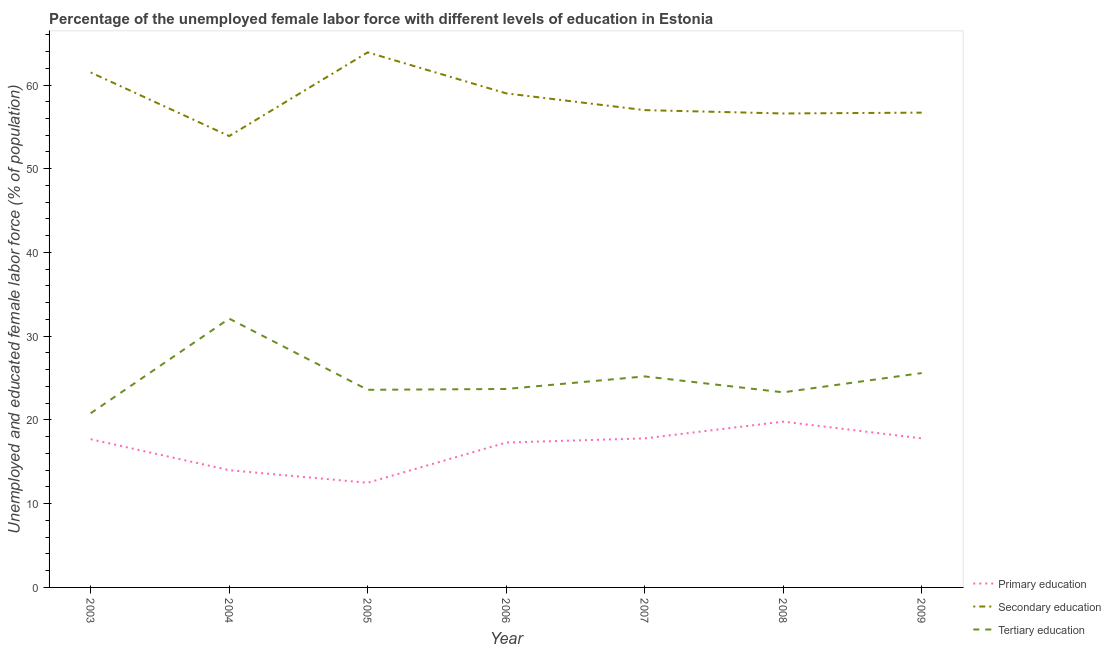Does the line corresponding to percentage of female labor force who received tertiary education intersect with the line corresponding to percentage of female labor force who received secondary education?
Ensure brevity in your answer.  No. Is the number of lines equal to the number of legend labels?
Make the answer very short. Yes. What is the percentage of female labor force who received secondary education in 2003?
Keep it short and to the point. 61.5. Across all years, what is the maximum percentage of female labor force who received primary education?
Keep it short and to the point. 19.8. Across all years, what is the minimum percentage of female labor force who received tertiary education?
Give a very brief answer. 20.8. What is the total percentage of female labor force who received secondary education in the graph?
Keep it short and to the point. 408.6. What is the difference between the percentage of female labor force who received primary education in 2003 and that in 2004?
Your response must be concise. 3.7. What is the difference between the percentage of female labor force who received primary education in 2008 and the percentage of female labor force who received secondary education in 2004?
Offer a very short reply. -34.1. What is the average percentage of female labor force who received secondary education per year?
Your answer should be very brief. 58.37. In the year 2006, what is the difference between the percentage of female labor force who received secondary education and percentage of female labor force who received primary education?
Keep it short and to the point. 41.7. In how many years, is the percentage of female labor force who received primary education greater than 54 %?
Your answer should be compact. 0. What is the ratio of the percentage of female labor force who received primary education in 2005 to that in 2007?
Make the answer very short. 0.7. Is the percentage of female labor force who received secondary education in 2005 less than that in 2006?
Provide a succinct answer. No. Is the difference between the percentage of female labor force who received tertiary education in 2003 and 2007 greater than the difference between the percentage of female labor force who received secondary education in 2003 and 2007?
Make the answer very short. No. What is the difference between the highest and the second highest percentage of female labor force who received primary education?
Provide a succinct answer. 2. What is the difference between the highest and the lowest percentage of female labor force who received tertiary education?
Offer a terse response. 11.3. Does the percentage of female labor force who received tertiary education monotonically increase over the years?
Provide a succinct answer. No. Is the percentage of female labor force who received primary education strictly greater than the percentage of female labor force who received tertiary education over the years?
Keep it short and to the point. No. Does the graph contain any zero values?
Offer a very short reply. No. Does the graph contain grids?
Make the answer very short. No. Where does the legend appear in the graph?
Provide a short and direct response. Bottom right. How many legend labels are there?
Your response must be concise. 3. How are the legend labels stacked?
Offer a terse response. Vertical. What is the title of the graph?
Your answer should be very brief. Percentage of the unemployed female labor force with different levels of education in Estonia. Does "Industry" appear as one of the legend labels in the graph?
Offer a very short reply. No. What is the label or title of the X-axis?
Make the answer very short. Year. What is the label or title of the Y-axis?
Keep it short and to the point. Unemployed and educated female labor force (% of population). What is the Unemployed and educated female labor force (% of population) in Primary education in 2003?
Make the answer very short. 17.7. What is the Unemployed and educated female labor force (% of population) of Secondary education in 2003?
Keep it short and to the point. 61.5. What is the Unemployed and educated female labor force (% of population) in Tertiary education in 2003?
Provide a succinct answer. 20.8. What is the Unemployed and educated female labor force (% of population) of Secondary education in 2004?
Your response must be concise. 53.9. What is the Unemployed and educated female labor force (% of population) in Tertiary education in 2004?
Your answer should be very brief. 32.1. What is the Unemployed and educated female labor force (% of population) of Secondary education in 2005?
Offer a very short reply. 63.9. What is the Unemployed and educated female labor force (% of population) of Tertiary education in 2005?
Your answer should be compact. 23.6. What is the Unemployed and educated female labor force (% of population) in Primary education in 2006?
Give a very brief answer. 17.3. What is the Unemployed and educated female labor force (% of population) of Tertiary education in 2006?
Provide a succinct answer. 23.7. What is the Unemployed and educated female labor force (% of population) in Primary education in 2007?
Your answer should be very brief. 17.8. What is the Unemployed and educated female labor force (% of population) in Tertiary education in 2007?
Your answer should be very brief. 25.2. What is the Unemployed and educated female labor force (% of population) of Primary education in 2008?
Your answer should be very brief. 19.8. What is the Unemployed and educated female labor force (% of population) of Secondary education in 2008?
Ensure brevity in your answer.  56.6. What is the Unemployed and educated female labor force (% of population) of Tertiary education in 2008?
Offer a very short reply. 23.3. What is the Unemployed and educated female labor force (% of population) of Primary education in 2009?
Offer a terse response. 17.8. What is the Unemployed and educated female labor force (% of population) of Secondary education in 2009?
Your answer should be very brief. 56.7. What is the Unemployed and educated female labor force (% of population) of Tertiary education in 2009?
Give a very brief answer. 25.6. Across all years, what is the maximum Unemployed and educated female labor force (% of population) of Primary education?
Your answer should be very brief. 19.8. Across all years, what is the maximum Unemployed and educated female labor force (% of population) of Secondary education?
Offer a very short reply. 63.9. Across all years, what is the maximum Unemployed and educated female labor force (% of population) of Tertiary education?
Offer a very short reply. 32.1. Across all years, what is the minimum Unemployed and educated female labor force (% of population) of Secondary education?
Give a very brief answer. 53.9. Across all years, what is the minimum Unemployed and educated female labor force (% of population) of Tertiary education?
Your response must be concise. 20.8. What is the total Unemployed and educated female labor force (% of population) in Primary education in the graph?
Provide a succinct answer. 116.9. What is the total Unemployed and educated female labor force (% of population) of Secondary education in the graph?
Offer a very short reply. 408.6. What is the total Unemployed and educated female labor force (% of population) of Tertiary education in the graph?
Offer a terse response. 174.3. What is the difference between the Unemployed and educated female labor force (% of population) of Primary education in 2003 and that in 2004?
Provide a succinct answer. 3.7. What is the difference between the Unemployed and educated female labor force (% of population) of Tertiary education in 2003 and that in 2004?
Provide a short and direct response. -11.3. What is the difference between the Unemployed and educated female labor force (% of population) of Secondary education in 2003 and that in 2005?
Your response must be concise. -2.4. What is the difference between the Unemployed and educated female labor force (% of population) of Tertiary education in 2003 and that in 2006?
Your answer should be very brief. -2.9. What is the difference between the Unemployed and educated female labor force (% of population) in Primary education in 2003 and that in 2007?
Give a very brief answer. -0.1. What is the difference between the Unemployed and educated female labor force (% of population) in Secondary education in 2003 and that in 2008?
Make the answer very short. 4.9. What is the difference between the Unemployed and educated female labor force (% of population) of Tertiary education in 2003 and that in 2008?
Offer a very short reply. -2.5. What is the difference between the Unemployed and educated female labor force (% of population) in Tertiary education in 2003 and that in 2009?
Keep it short and to the point. -4.8. What is the difference between the Unemployed and educated female labor force (% of population) of Primary education in 2004 and that in 2005?
Give a very brief answer. 1.5. What is the difference between the Unemployed and educated female labor force (% of population) in Tertiary education in 2004 and that in 2005?
Give a very brief answer. 8.5. What is the difference between the Unemployed and educated female labor force (% of population) of Secondary education in 2004 and that in 2006?
Keep it short and to the point. -5.1. What is the difference between the Unemployed and educated female labor force (% of population) of Secondary education in 2004 and that in 2007?
Offer a terse response. -3.1. What is the difference between the Unemployed and educated female labor force (% of population) of Tertiary education in 2004 and that in 2007?
Offer a terse response. 6.9. What is the difference between the Unemployed and educated female labor force (% of population) of Tertiary education in 2004 and that in 2008?
Offer a terse response. 8.8. What is the difference between the Unemployed and educated female labor force (% of population) in Primary education in 2004 and that in 2009?
Your answer should be very brief. -3.8. What is the difference between the Unemployed and educated female labor force (% of population) in Tertiary education in 2005 and that in 2006?
Keep it short and to the point. -0.1. What is the difference between the Unemployed and educated female labor force (% of population) of Secondary education in 2005 and that in 2007?
Keep it short and to the point. 6.9. What is the difference between the Unemployed and educated female labor force (% of population) in Tertiary education in 2005 and that in 2007?
Make the answer very short. -1.6. What is the difference between the Unemployed and educated female labor force (% of population) of Primary education in 2005 and that in 2008?
Make the answer very short. -7.3. What is the difference between the Unemployed and educated female labor force (% of population) of Secondary education in 2005 and that in 2008?
Make the answer very short. 7.3. What is the difference between the Unemployed and educated female labor force (% of population) in Tertiary education in 2005 and that in 2008?
Offer a very short reply. 0.3. What is the difference between the Unemployed and educated female labor force (% of population) in Primary education in 2005 and that in 2009?
Provide a succinct answer. -5.3. What is the difference between the Unemployed and educated female labor force (% of population) in Primary education in 2006 and that in 2007?
Ensure brevity in your answer.  -0.5. What is the difference between the Unemployed and educated female labor force (% of population) in Secondary education in 2006 and that in 2007?
Give a very brief answer. 2. What is the difference between the Unemployed and educated female labor force (% of population) of Tertiary education in 2006 and that in 2007?
Keep it short and to the point. -1.5. What is the difference between the Unemployed and educated female labor force (% of population) of Primary education in 2006 and that in 2008?
Your response must be concise. -2.5. What is the difference between the Unemployed and educated female labor force (% of population) of Secondary education in 2006 and that in 2009?
Offer a terse response. 2.3. What is the difference between the Unemployed and educated female labor force (% of population) of Tertiary education in 2006 and that in 2009?
Your answer should be very brief. -1.9. What is the difference between the Unemployed and educated female labor force (% of population) in Primary education in 2007 and that in 2008?
Offer a very short reply. -2. What is the difference between the Unemployed and educated female labor force (% of population) in Secondary education in 2007 and that in 2008?
Ensure brevity in your answer.  0.4. What is the difference between the Unemployed and educated female labor force (% of population) of Tertiary education in 2007 and that in 2008?
Make the answer very short. 1.9. What is the difference between the Unemployed and educated female labor force (% of population) of Primary education in 2008 and that in 2009?
Offer a terse response. 2. What is the difference between the Unemployed and educated female labor force (% of population) of Tertiary education in 2008 and that in 2009?
Offer a very short reply. -2.3. What is the difference between the Unemployed and educated female labor force (% of population) of Primary education in 2003 and the Unemployed and educated female labor force (% of population) of Secondary education in 2004?
Your response must be concise. -36.2. What is the difference between the Unemployed and educated female labor force (% of population) of Primary education in 2003 and the Unemployed and educated female labor force (% of population) of Tertiary education in 2004?
Provide a short and direct response. -14.4. What is the difference between the Unemployed and educated female labor force (% of population) in Secondary education in 2003 and the Unemployed and educated female labor force (% of population) in Tertiary education in 2004?
Offer a very short reply. 29.4. What is the difference between the Unemployed and educated female labor force (% of population) in Primary education in 2003 and the Unemployed and educated female labor force (% of population) in Secondary education in 2005?
Provide a succinct answer. -46.2. What is the difference between the Unemployed and educated female labor force (% of population) in Primary education in 2003 and the Unemployed and educated female labor force (% of population) in Tertiary education in 2005?
Give a very brief answer. -5.9. What is the difference between the Unemployed and educated female labor force (% of population) of Secondary education in 2003 and the Unemployed and educated female labor force (% of population) of Tertiary education in 2005?
Make the answer very short. 37.9. What is the difference between the Unemployed and educated female labor force (% of population) in Primary education in 2003 and the Unemployed and educated female labor force (% of population) in Secondary education in 2006?
Keep it short and to the point. -41.3. What is the difference between the Unemployed and educated female labor force (% of population) of Secondary education in 2003 and the Unemployed and educated female labor force (% of population) of Tertiary education in 2006?
Your answer should be very brief. 37.8. What is the difference between the Unemployed and educated female labor force (% of population) of Primary education in 2003 and the Unemployed and educated female labor force (% of population) of Secondary education in 2007?
Give a very brief answer. -39.3. What is the difference between the Unemployed and educated female labor force (% of population) of Secondary education in 2003 and the Unemployed and educated female labor force (% of population) of Tertiary education in 2007?
Your answer should be very brief. 36.3. What is the difference between the Unemployed and educated female labor force (% of population) in Primary education in 2003 and the Unemployed and educated female labor force (% of population) in Secondary education in 2008?
Keep it short and to the point. -38.9. What is the difference between the Unemployed and educated female labor force (% of population) of Primary education in 2003 and the Unemployed and educated female labor force (% of population) of Tertiary education in 2008?
Ensure brevity in your answer.  -5.6. What is the difference between the Unemployed and educated female labor force (% of population) of Secondary education in 2003 and the Unemployed and educated female labor force (% of population) of Tertiary education in 2008?
Ensure brevity in your answer.  38.2. What is the difference between the Unemployed and educated female labor force (% of population) of Primary education in 2003 and the Unemployed and educated female labor force (% of population) of Secondary education in 2009?
Ensure brevity in your answer.  -39. What is the difference between the Unemployed and educated female labor force (% of population) in Secondary education in 2003 and the Unemployed and educated female labor force (% of population) in Tertiary education in 2009?
Keep it short and to the point. 35.9. What is the difference between the Unemployed and educated female labor force (% of population) of Primary education in 2004 and the Unemployed and educated female labor force (% of population) of Secondary education in 2005?
Provide a succinct answer. -49.9. What is the difference between the Unemployed and educated female labor force (% of population) in Secondary education in 2004 and the Unemployed and educated female labor force (% of population) in Tertiary education in 2005?
Your answer should be compact. 30.3. What is the difference between the Unemployed and educated female labor force (% of population) of Primary education in 2004 and the Unemployed and educated female labor force (% of population) of Secondary education in 2006?
Provide a succinct answer. -45. What is the difference between the Unemployed and educated female labor force (% of population) in Secondary education in 2004 and the Unemployed and educated female labor force (% of population) in Tertiary education in 2006?
Your response must be concise. 30.2. What is the difference between the Unemployed and educated female labor force (% of population) in Primary education in 2004 and the Unemployed and educated female labor force (% of population) in Secondary education in 2007?
Offer a very short reply. -43. What is the difference between the Unemployed and educated female labor force (% of population) in Primary education in 2004 and the Unemployed and educated female labor force (% of population) in Tertiary education in 2007?
Your answer should be compact. -11.2. What is the difference between the Unemployed and educated female labor force (% of population) in Secondary education in 2004 and the Unemployed and educated female labor force (% of population) in Tertiary education in 2007?
Your answer should be compact. 28.7. What is the difference between the Unemployed and educated female labor force (% of population) in Primary education in 2004 and the Unemployed and educated female labor force (% of population) in Secondary education in 2008?
Keep it short and to the point. -42.6. What is the difference between the Unemployed and educated female labor force (% of population) in Secondary education in 2004 and the Unemployed and educated female labor force (% of population) in Tertiary education in 2008?
Your answer should be compact. 30.6. What is the difference between the Unemployed and educated female labor force (% of population) of Primary education in 2004 and the Unemployed and educated female labor force (% of population) of Secondary education in 2009?
Keep it short and to the point. -42.7. What is the difference between the Unemployed and educated female labor force (% of population) in Primary education in 2004 and the Unemployed and educated female labor force (% of population) in Tertiary education in 2009?
Your answer should be compact. -11.6. What is the difference between the Unemployed and educated female labor force (% of population) of Secondary education in 2004 and the Unemployed and educated female labor force (% of population) of Tertiary education in 2009?
Offer a terse response. 28.3. What is the difference between the Unemployed and educated female labor force (% of population) in Primary education in 2005 and the Unemployed and educated female labor force (% of population) in Secondary education in 2006?
Give a very brief answer. -46.5. What is the difference between the Unemployed and educated female labor force (% of population) of Primary education in 2005 and the Unemployed and educated female labor force (% of population) of Tertiary education in 2006?
Provide a short and direct response. -11.2. What is the difference between the Unemployed and educated female labor force (% of population) of Secondary education in 2005 and the Unemployed and educated female labor force (% of population) of Tertiary education in 2006?
Make the answer very short. 40.2. What is the difference between the Unemployed and educated female labor force (% of population) of Primary education in 2005 and the Unemployed and educated female labor force (% of population) of Secondary education in 2007?
Give a very brief answer. -44.5. What is the difference between the Unemployed and educated female labor force (% of population) of Secondary education in 2005 and the Unemployed and educated female labor force (% of population) of Tertiary education in 2007?
Make the answer very short. 38.7. What is the difference between the Unemployed and educated female labor force (% of population) in Primary education in 2005 and the Unemployed and educated female labor force (% of population) in Secondary education in 2008?
Ensure brevity in your answer.  -44.1. What is the difference between the Unemployed and educated female labor force (% of population) in Secondary education in 2005 and the Unemployed and educated female labor force (% of population) in Tertiary education in 2008?
Your response must be concise. 40.6. What is the difference between the Unemployed and educated female labor force (% of population) in Primary education in 2005 and the Unemployed and educated female labor force (% of population) in Secondary education in 2009?
Your answer should be compact. -44.2. What is the difference between the Unemployed and educated female labor force (% of population) in Primary education in 2005 and the Unemployed and educated female labor force (% of population) in Tertiary education in 2009?
Offer a very short reply. -13.1. What is the difference between the Unemployed and educated female labor force (% of population) in Secondary education in 2005 and the Unemployed and educated female labor force (% of population) in Tertiary education in 2009?
Keep it short and to the point. 38.3. What is the difference between the Unemployed and educated female labor force (% of population) in Primary education in 2006 and the Unemployed and educated female labor force (% of population) in Secondary education in 2007?
Offer a terse response. -39.7. What is the difference between the Unemployed and educated female labor force (% of population) of Primary education in 2006 and the Unemployed and educated female labor force (% of population) of Tertiary education in 2007?
Make the answer very short. -7.9. What is the difference between the Unemployed and educated female labor force (% of population) in Secondary education in 2006 and the Unemployed and educated female labor force (% of population) in Tertiary education in 2007?
Offer a very short reply. 33.8. What is the difference between the Unemployed and educated female labor force (% of population) of Primary education in 2006 and the Unemployed and educated female labor force (% of population) of Secondary education in 2008?
Make the answer very short. -39.3. What is the difference between the Unemployed and educated female labor force (% of population) of Secondary education in 2006 and the Unemployed and educated female labor force (% of population) of Tertiary education in 2008?
Your answer should be compact. 35.7. What is the difference between the Unemployed and educated female labor force (% of population) of Primary education in 2006 and the Unemployed and educated female labor force (% of population) of Secondary education in 2009?
Make the answer very short. -39.4. What is the difference between the Unemployed and educated female labor force (% of population) in Secondary education in 2006 and the Unemployed and educated female labor force (% of population) in Tertiary education in 2009?
Offer a terse response. 33.4. What is the difference between the Unemployed and educated female labor force (% of population) of Primary education in 2007 and the Unemployed and educated female labor force (% of population) of Secondary education in 2008?
Ensure brevity in your answer.  -38.8. What is the difference between the Unemployed and educated female labor force (% of population) in Secondary education in 2007 and the Unemployed and educated female labor force (% of population) in Tertiary education in 2008?
Ensure brevity in your answer.  33.7. What is the difference between the Unemployed and educated female labor force (% of population) in Primary education in 2007 and the Unemployed and educated female labor force (% of population) in Secondary education in 2009?
Ensure brevity in your answer.  -38.9. What is the difference between the Unemployed and educated female labor force (% of population) of Primary education in 2007 and the Unemployed and educated female labor force (% of population) of Tertiary education in 2009?
Offer a very short reply. -7.8. What is the difference between the Unemployed and educated female labor force (% of population) in Secondary education in 2007 and the Unemployed and educated female labor force (% of population) in Tertiary education in 2009?
Provide a succinct answer. 31.4. What is the difference between the Unemployed and educated female labor force (% of population) in Primary education in 2008 and the Unemployed and educated female labor force (% of population) in Secondary education in 2009?
Ensure brevity in your answer.  -36.9. What is the difference between the Unemployed and educated female labor force (% of population) in Secondary education in 2008 and the Unemployed and educated female labor force (% of population) in Tertiary education in 2009?
Provide a short and direct response. 31. What is the average Unemployed and educated female labor force (% of population) of Secondary education per year?
Ensure brevity in your answer.  58.37. What is the average Unemployed and educated female labor force (% of population) in Tertiary education per year?
Your answer should be very brief. 24.9. In the year 2003, what is the difference between the Unemployed and educated female labor force (% of population) of Primary education and Unemployed and educated female labor force (% of population) of Secondary education?
Offer a very short reply. -43.8. In the year 2003, what is the difference between the Unemployed and educated female labor force (% of population) in Primary education and Unemployed and educated female labor force (% of population) in Tertiary education?
Make the answer very short. -3.1. In the year 2003, what is the difference between the Unemployed and educated female labor force (% of population) of Secondary education and Unemployed and educated female labor force (% of population) of Tertiary education?
Ensure brevity in your answer.  40.7. In the year 2004, what is the difference between the Unemployed and educated female labor force (% of population) of Primary education and Unemployed and educated female labor force (% of population) of Secondary education?
Your answer should be compact. -39.9. In the year 2004, what is the difference between the Unemployed and educated female labor force (% of population) of Primary education and Unemployed and educated female labor force (% of population) of Tertiary education?
Offer a terse response. -18.1. In the year 2004, what is the difference between the Unemployed and educated female labor force (% of population) of Secondary education and Unemployed and educated female labor force (% of population) of Tertiary education?
Your answer should be very brief. 21.8. In the year 2005, what is the difference between the Unemployed and educated female labor force (% of population) of Primary education and Unemployed and educated female labor force (% of population) of Secondary education?
Your answer should be compact. -51.4. In the year 2005, what is the difference between the Unemployed and educated female labor force (% of population) of Primary education and Unemployed and educated female labor force (% of population) of Tertiary education?
Provide a succinct answer. -11.1. In the year 2005, what is the difference between the Unemployed and educated female labor force (% of population) in Secondary education and Unemployed and educated female labor force (% of population) in Tertiary education?
Your answer should be compact. 40.3. In the year 2006, what is the difference between the Unemployed and educated female labor force (% of population) of Primary education and Unemployed and educated female labor force (% of population) of Secondary education?
Give a very brief answer. -41.7. In the year 2006, what is the difference between the Unemployed and educated female labor force (% of population) of Primary education and Unemployed and educated female labor force (% of population) of Tertiary education?
Keep it short and to the point. -6.4. In the year 2006, what is the difference between the Unemployed and educated female labor force (% of population) of Secondary education and Unemployed and educated female labor force (% of population) of Tertiary education?
Your response must be concise. 35.3. In the year 2007, what is the difference between the Unemployed and educated female labor force (% of population) of Primary education and Unemployed and educated female labor force (% of population) of Secondary education?
Your response must be concise. -39.2. In the year 2007, what is the difference between the Unemployed and educated female labor force (% of population) of Primary education and Unemployed and educated female labor force (% of population) of Tertiary education?
Provide a short and direct response. -7.4. In the year 2007, what is the difference between the Unemployed and educated female labor force (% of population) in Secondary education and Unemployed and educated female labor force (% of population) in Tertiary education?
Keep it short and to the point. 31.8. In the year 2008, what is the difference between the Unemployed and educated female labor force (% of population) in Primary education and Unemployed and educated female labor force (% of population) in Secondary education?
Make the answer very short. -36.8. In the year 2008, what is the difference between the Unemployed and educated female labor force (% of population) in Primary education and Unemployed and educated female labor force (% of population) in Tertiary education?
Give a very brief answer. -3.5. In the year 2008, what is the difference between the Unemployed and educated female labor force (% of population) of Secondary education and Unemployed and educated female labor force (% of population) of Tertiary education?
Offer a very short reply. 33.3. In the year 2009, what is the difference between the Unemployed and educated female labor force (% of population) of Primary education and Unemployed and educated female labor force (% of population) of Secondary education?
Ensure brevity in your answer.  -38.9. In the year 2009, what is the difference between the Unemployed and educated female labor force (% of population) in Secondary education and Unemployed and educated female labor force (% of population) in Tertiary education?
Your answer should be very brief. 31.1. What is the ratio of the Unemployed and educated female labor force (% of population) in Primary education in 2003 to that in 2004?
Provide a short and direct response. 1.26. What is the ratio of the Unemployed and educated female labor force (% of population) in Secondary education in 2003 to that in 2004?
Your answer should be very brief. 1.14. What is the ratio of the Unemployed and educated female labor force (% of population) of Tertiary education in 2003 to that in 2004?
Offer a terse response. 0.65. What is the ratio of the Unemployed and educated female labor force (% of population) of Primary education in 2003 to that in 2005?
Your answer should be compact. 1.42. What is the ratio of the Unemployed and educated female labor force (% of population) of Secondary education in 2003 to that in 2005?
Provide a short and direct response. 0.96. What is the ratio of the Unemployed and educated female labor force (% of population) of Tertiary education in 2003 to that in 2005?
Your answer should be compact. 0.88. What is the ratio of the Unemployed and educated female labor force (% of population) in Primary education in 2003 to that in 2006?
Provide a succinct answer. 1.02. What is the ratio of the Unemployed and educated female labor force (% of population) of Secondary education in 2003 to that in 2006?
Ensure brevity in your answer.  1.04. What is the ratio of the Unemployed and educated female labor force (% of population) of Tertiary education in 2003 to that in 2006?
Your response must be concise. 0.88. What is the ratio of the Unemployed and educated female labor force (% of population) of Secondary education in 2003 to that in 2007?
Your answer should be very brief. 1.08. What is the ratio of the Unemployed and educated female labor force (% of population) in Tertiary education in 2003 to that in 2007?
Make the answer very short. 0.83. What is the ratio of the Unemployed and educated female labor force (% of population) of Primary education in 2003 to that in 2008?
Offer a very short reply. 0.89. What is the ratio of the Unemployed and educated female labor force (% of population) of Secondary education in 2003 to that in 2008?
Keep it short and to the point. 1.09. What is the ratio of the Unemployed and educated female labor force (% of population) in Tertiary education in 2003 to that in 2008?
Ensure brevity in your answer.  0.89. What is the ratio of the Unemployed and educated female labor force (% of population) in Secondary education in 2003 to that in 2009?
Your answer should be very brief. 1.08. What is the ratio of the Unemployed and educated female labor force (% of population) of Tertiary education in 2003 to that in 2009?
Make the answer very short. 0.81. What is the ratio of the Unemployed and educated female labor force (% of population) in Primary education in 2004 to that in 2005?
Provide a succinct answer. 1.12. What is the ratio of the Unemployed and educated female labor force (% of population) of Secondary education in 2004 to that in 2005?
Your answer should be compact. 0.84. What is the ratio of the Unemployed and educated female labor force (% of population) of Tertiary education in 2004 to that in 2005?
Offer a very short reply. 1.36. What is the ratio of the Unemployed and educated female labor force (% of population) in Primary education in 2004 to that in 2006?
Give a very brief answer. 0.81. What is the ratio of the Unemployed and educated female labor force (% of population) in Secondary education in 2004 to that in 2006?
Provide a short and direct response. 0.91. What is the ratio of the Unemployed and educated female labor force (% of population) of Tertiary education in 2004 to that in 2006?
Offer a very short reply. 1.35. What is the ratio of the Unemployed and educated female labor force (% of population) of Primary education in 2004 to that in 2007?
Keep it short and to the point. 0.79. What is the ratio of the Unemployed and educated female labor force (% of population) in Secondary education in 2004 to that in 2007?
Ensure brevity in your answer.  0.95. What is the ratio of the Unemployed and educated female labor force (% of population) in Tertiary education in 2004 to that in 2007?
Your response must be concise. 1.27. What is the ratio of the Unemployed and educated female labor force (% of population) of Primary education in 2004 to that in 2008?
Your answer should be compact. 0.71. What is the ratio of the Unemployed and educated female labor force (% of population) of Secondary education in 2004 to that in 2008?
Make the answer very short. 0.95. What is the ratio of the Unemployed and educated female labor force (% of population) in Tertiary education in 2004 to that in 2008?
Keep it short and to the point. 1.38. What is the ratio of the Unemployed and educated female labor force (% of population) in Primary education in 2004 to that in 2009?
Keep it short and to the point. 0.79. What is the ratio of the Unemployed and educated female labor force (% of population) in Secondary education in 2004 to that in 2009?
Provide a succinct answer. 0.95. What is the ratio of the Unemployed and educated female labor force (% of population) of Tertiary education in 2004 to that in 2009?
Provide a succinct answer. 1.25. What is the ratio of the Unemployed and educated female labor force (% of population) in Primary education in 2005 to that in 2006?
Offer a very short reply. 0.72. What is the ratio of the Unemployed and educated female labor force (% of population) of Secondary education in 2005 to that in 2006?
Offer a very short reply. 1.08. What is the ratio of the Unemployed and educated female labor force (% of population) in Primary education in 2005 to that in 2007?
Your answer should be compact. 0.7. What is the ratio of the Unemployed and educated female labor force (% of population) in Secondary education in 2005 to that in 2007?
Offer a very short reply. 1.12. What is the ratio of the Unemployed and educated female labor force (% of population) in Tertiary education in 2005 to that in 2007?
Provide a short and direct response. 0.94. What is the ratio of the Unemployed and educated female labor force (% of population) of Primary education in 2005 to that in 2008?
Provide a succinct answer. 0.63. What is the ratio of the Unemployed and educated female labor force (% of population) in Secondary education in 2005 to that in 2008?
Make the answer very short. 1.13. What is the ratio of the Unemployed and educated female labor force (% of population) of Tertiary education in 2005 to that in 2008?
Your answer should be compact. 1.01. What is the ratio of the Unemployed and educated female labor force (% of population) in Primary education in 2005 to that in 2009?
Ensure brevity in your answer.  0.7. What is the ratio of the Unemployed and educated female labor force (% of population) of Secondary education in 2005 to that in 2009?
Ensure brevity in your answer.  1.13. What is the ratio of the Unemployed and educated female labor force (% of population) in Tertiary education in 2005 to that in 2009?
Your answer should be compact. 0.92. What is the ratio of the Unemployed and educated female labor force (% of population) in Primary education in 2006 to that in 2007?
Give a very brief answer. 0.97. What is the ratio of the Unemployed and educated female labor force (% of population) of Secondary education in 2006 to that in 2007?
Your answer should be very brief. 1.04. What is the ratio of the Unemployed and educated female labor force (% of population) in Tertiary education in 2006 to that in 2007?
Keep it short and to the point. 0.94. What is the ratio of the Unemployed and educated female labor force (% of population) of Primary education in 2006 to that in 2008?
Provide a succinct answer. 0.87. What is the ratio of the Unemployed and educated female labor force (% of population) in Secondary education in 2006 to that in 2008?
Your answer should be compact. 1.04. What is the ratio of the Unemployed and educated female labor force (% of population) of Tertiary education in 2006 to that in 2008?
Your answer should be very brief. 1.02. What is the ratio of the Unemployed and educated female labor force (% of population) in Primary education in 2006 to that in 2009?
Your answer should be very brief. 0.97. What is the ratio of the Unemployed and educated female labor force (% of population) of Secondary education in 2006 to that in 2009?
Offer a terse response. 1.04. What is the ratio of the Unemployed and educated female labor force (% of population) in Tertiary education in 2006 to that in 2009?
Your response must be concise. 0.93. What is the ratio of the Unemployed and educated female labor force (% of population) of Primary education in 2007 to that in 2008?
Make the answer very short. 0.9. What is the ratio of the Unemployed and educated female labor force (% of population) in Secondary education in 2007 to that in 2008?
Give a very brief answer. 1.01. What is the ratio of the Unemployed and educated female labor force (% of population) of Tertiary education in 2007 to that in 2008?
Make the answer very short. 1.08. What is the ratio of the Unemployed and educated female labor force (% of population) of Tertiary education in 2007 to that in 2009?
Provide a succinct answer. 0.98. What is the ratio of the Unemployed and educated female labor force (% of population) of Primary education in 2008 to that in 2009?
Make the answer very short. 1.11. What is the ratio of the Unemployed and educated female labor force (% of population) in Secondary education in 2008 to that in 2009?
Offer a very short reply. 1. What is the ratio of the Unemployed and educated female labor force (% of population) in Tertiary education in 2008 to that in 2009?
Your response must be concise. 0.91. What is the difference between the highest and the second highest Unemployed and educated female labor force (% of population) in Tertiary education?
Provide a succinct answer. 6.5. What is the difference between the highest and the lowest Unemployed and educated female labor force (% of population) of Primary education?
Your answer should be very brief. 7.3. What is the difference between the highest and the lowest Unemployed and educated female labor force (% of population) in Secondary education?
Your answer should be compact. 10. 